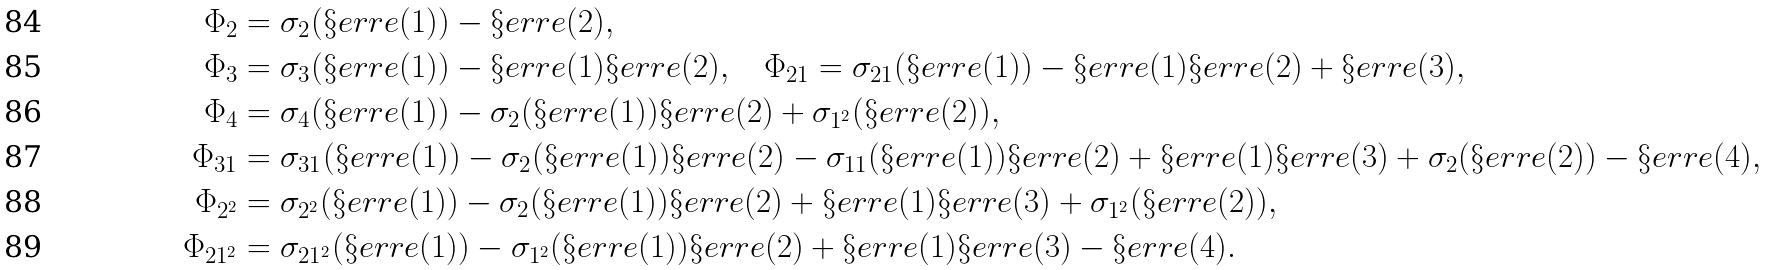<formula> <loc_0><loc_0><loc_500><loc_500>\Phi _ { 2 } & = \sigma _ { 2 } ( \S e r r e ( 1 ) ) - \S e r r e ( 2 ) , \\ \Phi _ { 3 } & = \sigma _ { 3 } ( \S e r r e ( 1 ) ) - \S e r r e ( 1 ) \S e r r e ( 2 ) , \quad \Phi _ { 2 1 } = \sigma _ { 2 1 } ( \S e r r e ( 1 ) ) - \S e r r e ( 1 ) \S e r r e ( 2 ) + \S e r r e ( 3 ) , \\ \Phi _ { 4 } & = \sigma _ { 4 } ( \S e r r e ( 1 ) ) - \sigma _ { 2 } ( \S e r r e ( 1 ) ) \S e r r e ( 2 ) + \sigma _ { 1 ^ { 2 } } ( \S e r r e ( 2 ) ) , \\ \Phi _ { 3 1 } & = \sigma _ { 3 1 } ( \S e r r e ( 1 ) ) - \sigma _ { 2 } ( \S e r r e ( 1 ) ) \S e r r e ( 2 ) - \sigma _ { 1 1 } ( \S e r r e ( 1 ) ) \S e r r e ( 2 ) + \S e r r e ( 1 ) \S e r r e ( 3 ) + \sigma _ { 2 } ( \S e r r e ( 2 ) ) - \S e r r e ( 4 ) , \\ \Phi _ { 2 ^ { 2 } } & = \sigma _ { 2 ^ { 2 } } ( \S e r r e ( 1 ) ) - \sigma _ { 2 } ( \S e r r e ( 1 ) ) \S e r r e ( 2 ) + \S e r r e ( 1 ) \S e r r e ( 3 ) + \sigma _ { 1 ^ { 2 } } ( \S e r r e ( 2 ) ) , \\ \Phi _ { 2 1 ^ { 2 } } & = \sigma _ { 2 1 ^ { 2 } } ( \S e r r e ( 1 ) ) - \sigma _ { 1 ^ { 2 } } ( \S e r r e ( 1 ) ) \S e r r e ( 2 ) + \S e r r e ( 1 ) \S e r r e ( 3 ) - \S e r r e ( 4 ) .</formula> 